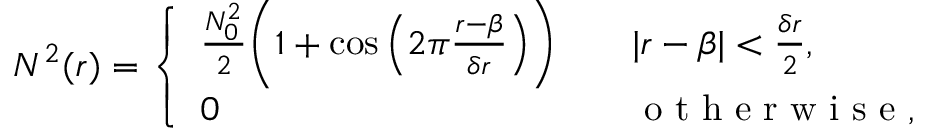Convert formula to latex. <formula><loc_0><loc_0><loc_500><loc_500>N ^ { 2 } ( r ) = \left \{ \begin{array} { l l } { \frac { N _ { 0 } ^ { 2 } } { 2 } \left ( 1 + \cos \left ( 2 \pi \frac { r - \beta } { \delta r } \right ) \right ) \quad } & { | r - \beta | < \frac { \delta r } { 2 } , } \\ { 0 \quad } & { o t h e r w i s e , } \end{array}</formula> 